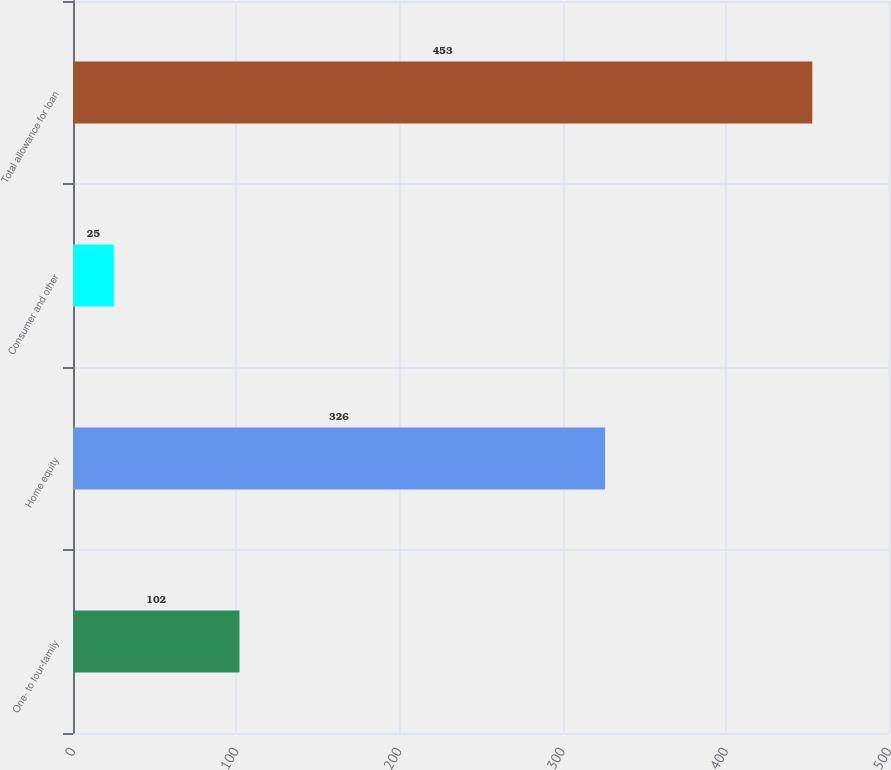<chart> <loc_0><loc_0><loc_500><loc_500><bar_chart><fcel>One- to four-family<fcel>Home equity<fcel>Consumer and other<fcel>Total allowance for loan<nl><fcel>102<fcel>326<fcel>25<fcel>453<nl></chart> 